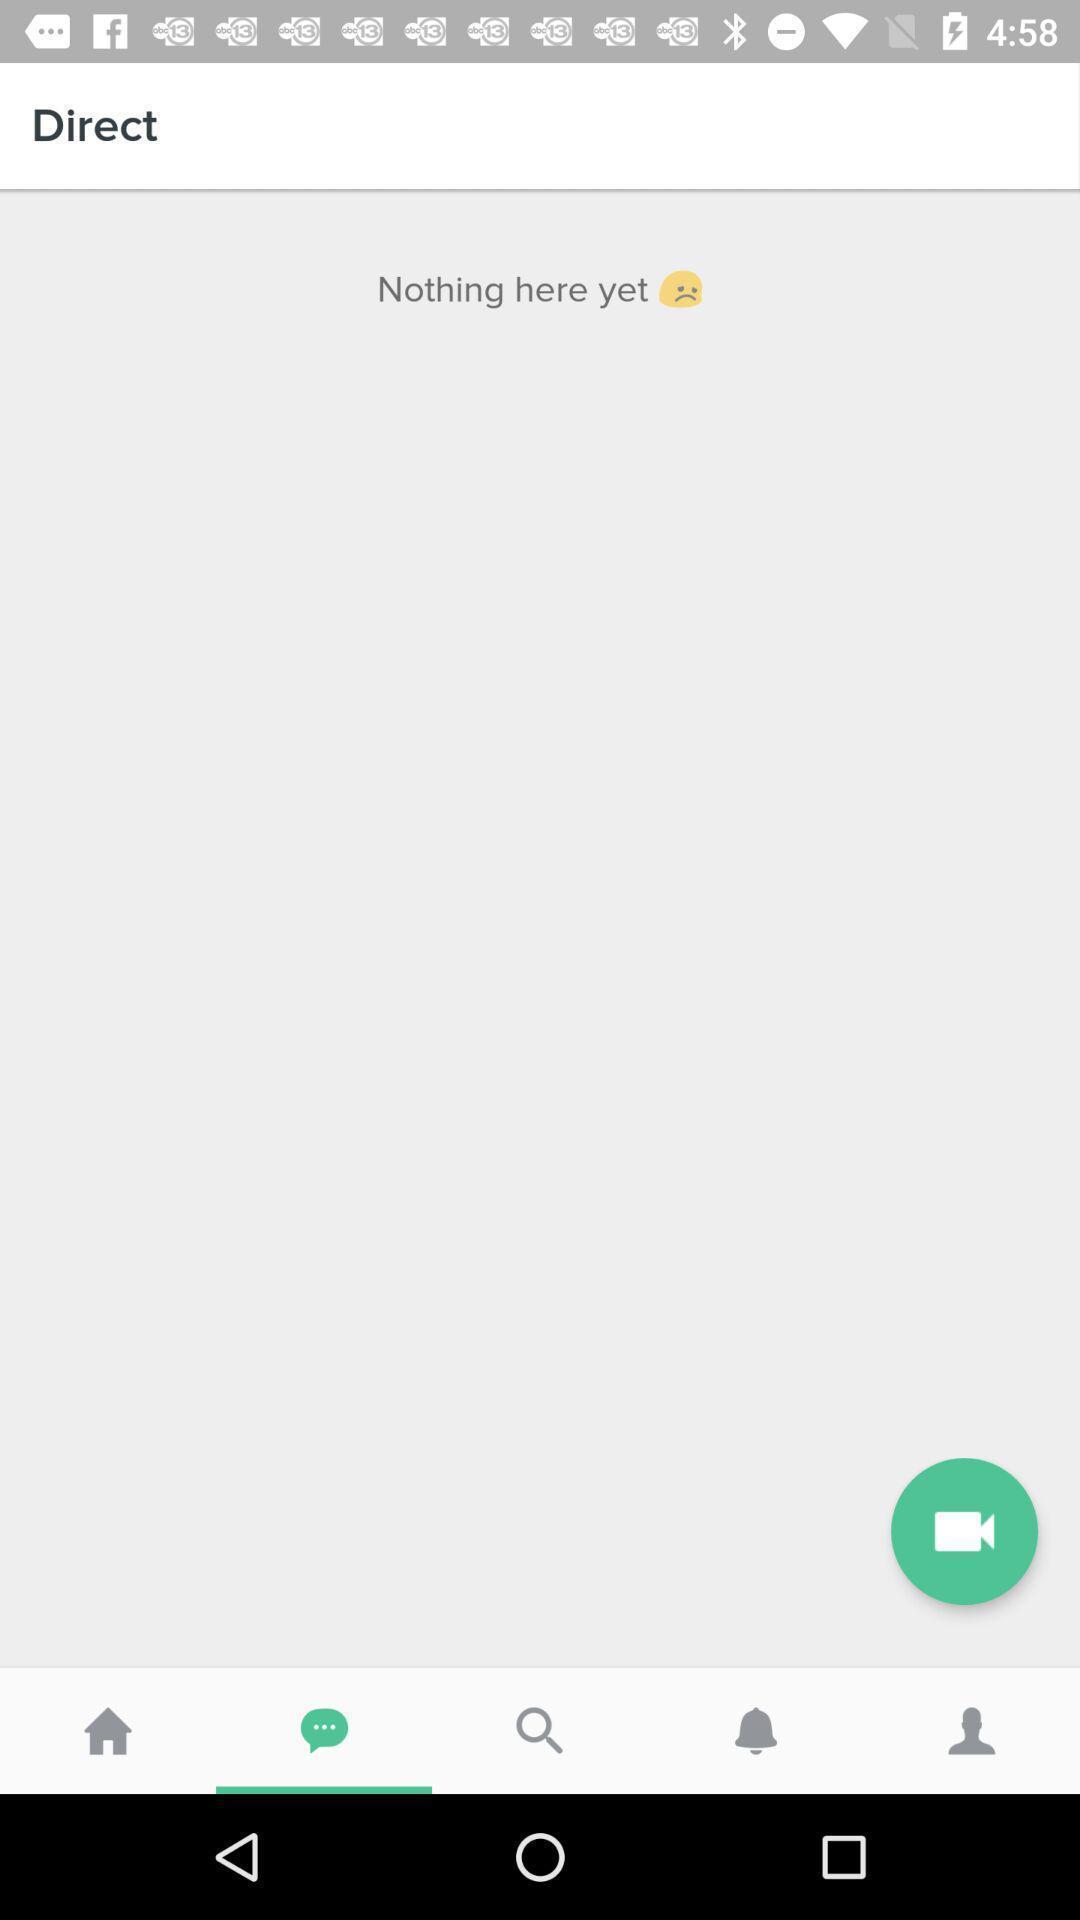Tell me about the visual elements in this screen capture. Screen shows direct option. 